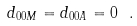Convert formula to latex. <formula><loc_0><loc_0><loc_500><loc_500>d _ { 0 0 M } = d _ { 0 0 A } = 0 \ .</formula> 